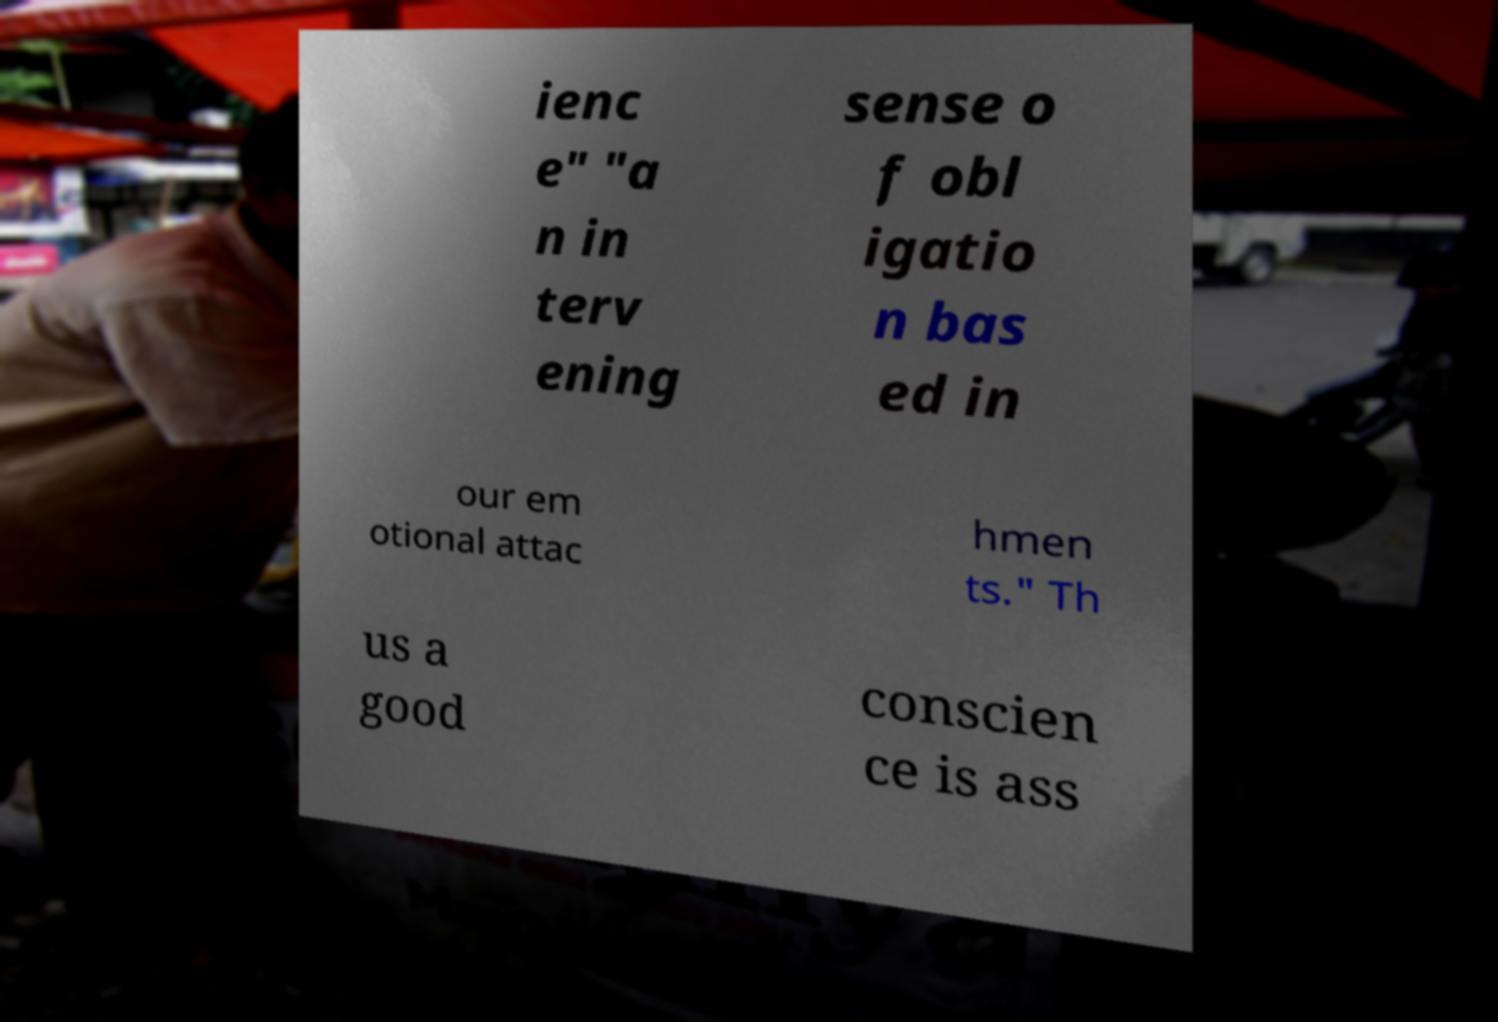Please identify and transcribe the text found in this image. ienc e" "a n in terv ening sense o f obl igatio n bas ed in our em otional attac hmen ts." Th us a good conscien ce is ass 